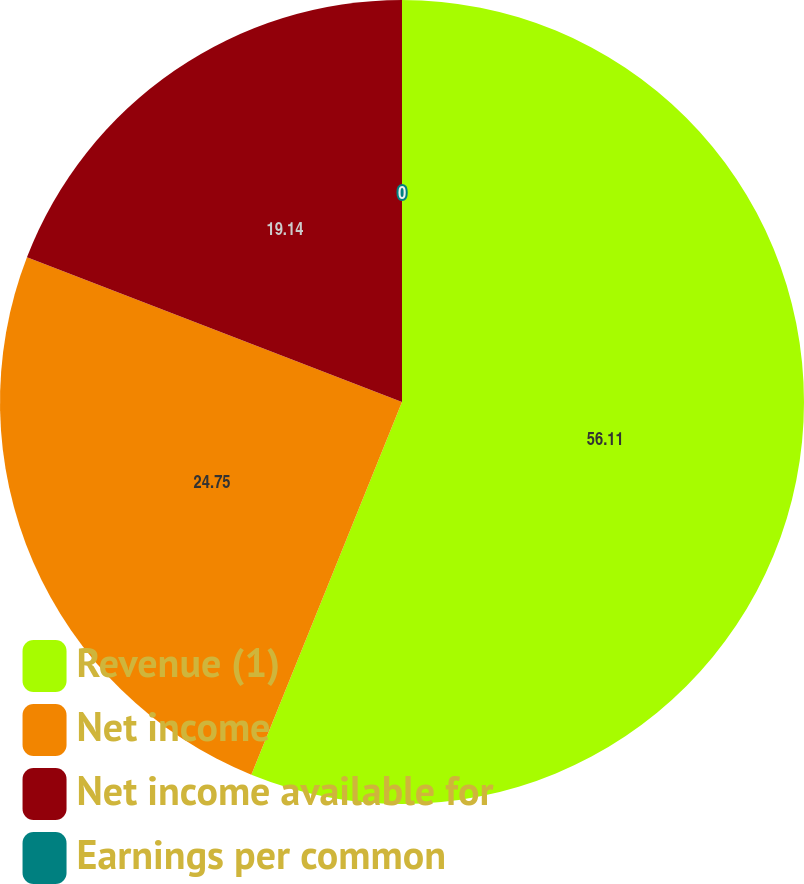Convert chart to OTSL. <chart><loc_0><loc_0><loc_500><loc_500><pie_chart><fcel>Revenue (1)<fcel>Net income<fcel>Net income available for<fcel>Earnings per common<nl><fcel>56.12%<fcel>24.75%<fcel>19.14%<fcel>0.0%<nl></chart> 